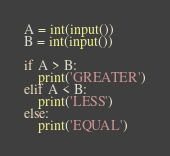Convert code to text. <code><loc_0><loc_0><loc_500><loc_500><_Python_>A = int(input())
B = int(input())

if A > B:
    print('GREATER')
elif A < B:
    print('LESS')
else:
    print('EQUAL')
</code> 